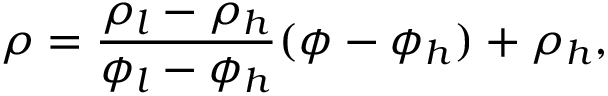Convert formula to latex. <formula><loc_0><loc_0><loc_500><loc_500>\rho = \frac { \rho _ { l } - \rho _ { h } } { \phi _ { l } - \phi _ { h } } ( \phi - \phi _ { h } ) + \rho _ { h } ,</formula> 